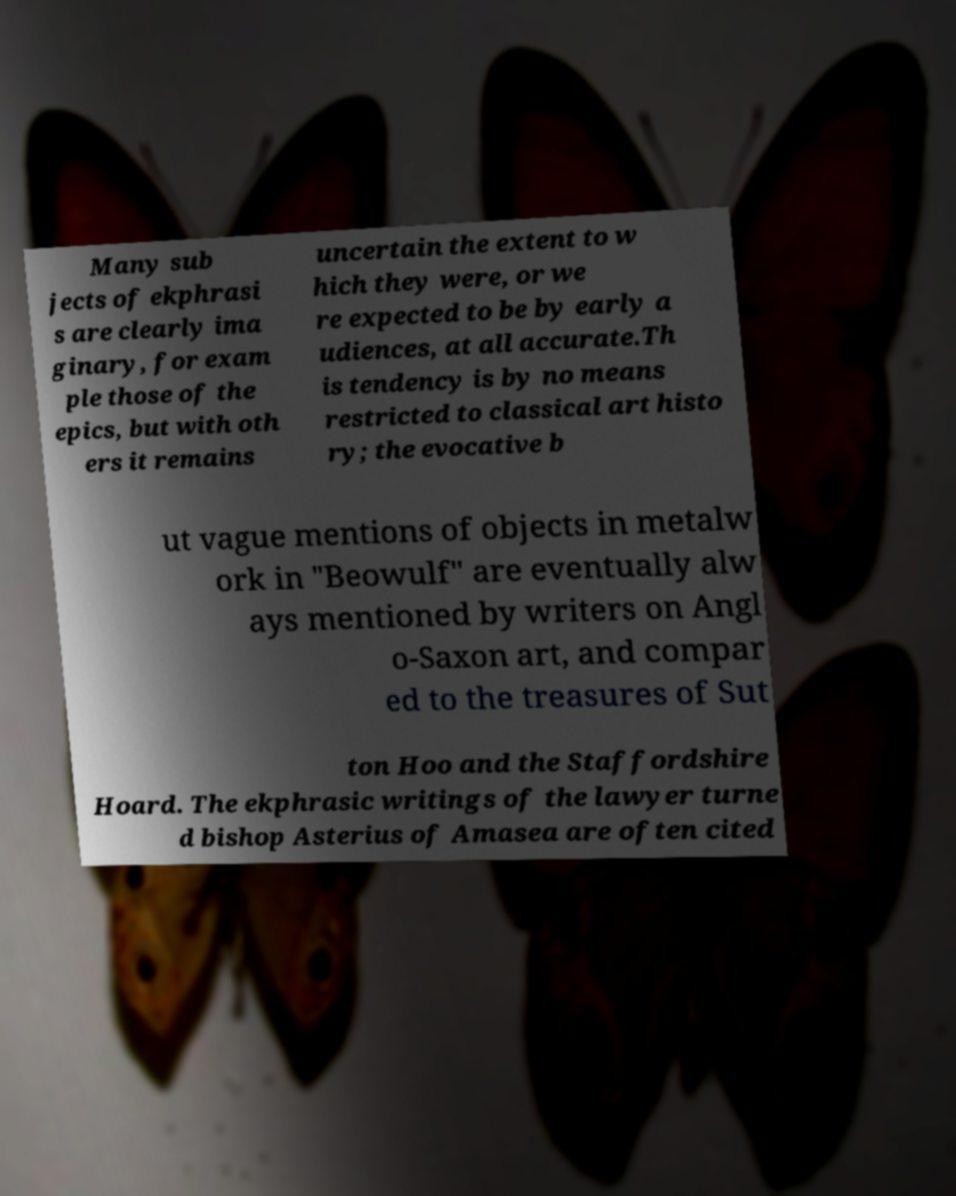Can you accurately transcribe the text from the provided image for me? Many sub jects of ekphrasi s are clearly ima ginary, for exam ple those of the epics, but with oth ers it remains uncertain the extent to w hich they were, or we re expected to be by early a udiences, at all accurate.Th is tendency is by no means restricted to classical art histo ry; the evocative b ut vague mentions of objects in metalw ork in "Beowulf" are eventually alw ays mentioned by writers on Angl o-Saxon art, and compar ed to the treasures of Sut ton Hoo and the Staffordshire Hoard. The ekphrasic writings of the lawyer turne d bishop Asterius of Amasea are often cited 